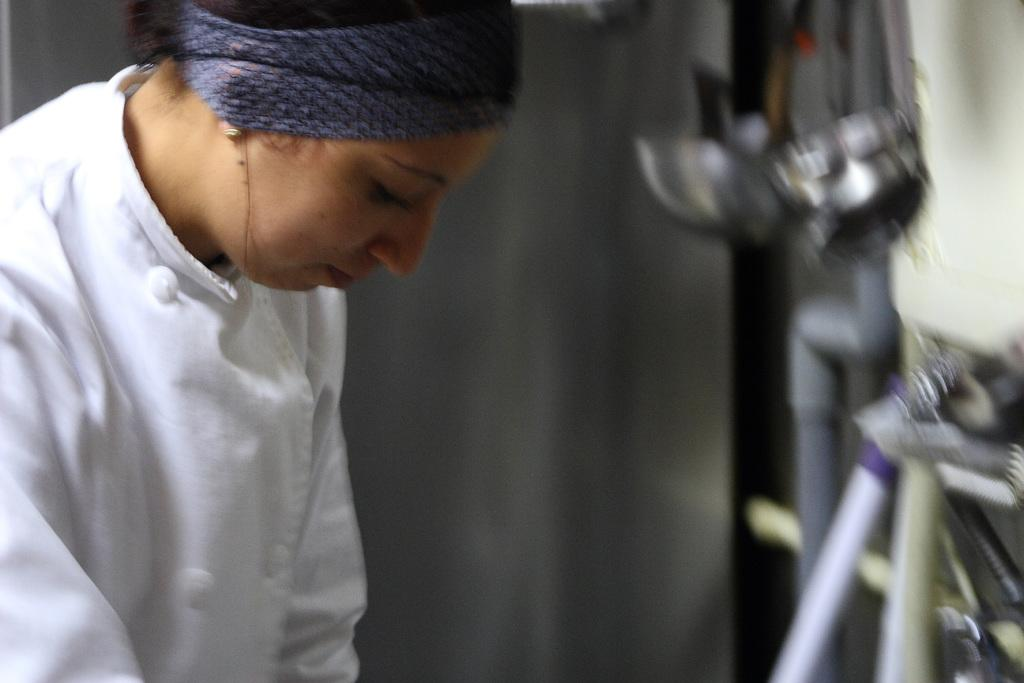What is the main subject of the image? There is a person standing in the image. What is the person wearing? The person is wearing a white dress. Can you describe the background of the image? The background of the image is blurred. What type of learning material can be seen in the person's hand in the image? There is no learning material visible in the person's hand in the image. Is there a train passing by in the background of the image? There is no train present in the image; the background is blurred. 